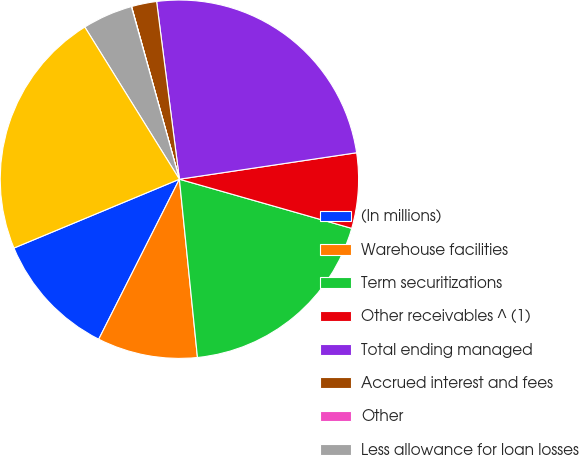Convert chart to OTSL. <chart><loc_0><loc_0><loc_500><loc_500><pie_chart><fcel>(In millions)<fcel>Warehouse facilities<fcel>Term securitizations<fcel>Other receivables ^ (1)<fcel>Total ending managed<fcel>Accrued interest and fees<fcel>Other<fcel>Less allowance for loan losses<fcel>Auto loan receivables net<nl><fcel>11.29%<fcel>9.04%<fcel>18.97%<fcel>6.78%<fcel>24.67%<fcel>2.27%<fcel>0.02%<fcel>4.53%<fcel>22.42%<nl></chart> 